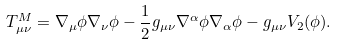Convert formula to latex. <formula><loc_0><loc_0><loc_500><loc_500>T ^ { M } _ { \mu \nu } = \nabla _ { \mu } \phi \nabla _ { \nu } \phi - \frac { 1 } { 2 } g _ { \mu \nu } \nabla ^ { \alpha } \phi \nabla _ { \alpha } \phi - g _ { \mu \nu } V _ { 2 } ( \phi ) .</formula> 